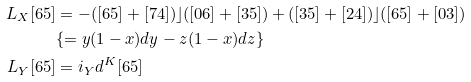<formula> <loc_0><loc_0><loc_500><loc_500>L _ { X } [ 6 5 ] & = - ( [ 6 5 ] + [ 7 4 ] ) \rfloor ( [ 0 6 ] + [ 3 5 ] ) + ( [ 3 5 ] + [ 2 4 ] ) \rfloor ( [ 6 5 ] + [ 0 3 ] ) \\ & \{ = y ( 1 - x ) d y - z ( 1 - x ) d z \} \\ L _ { Y } [ 6 5 ] & = i _ { Y } d ^ { K } [ 6 5 ]</formula> 